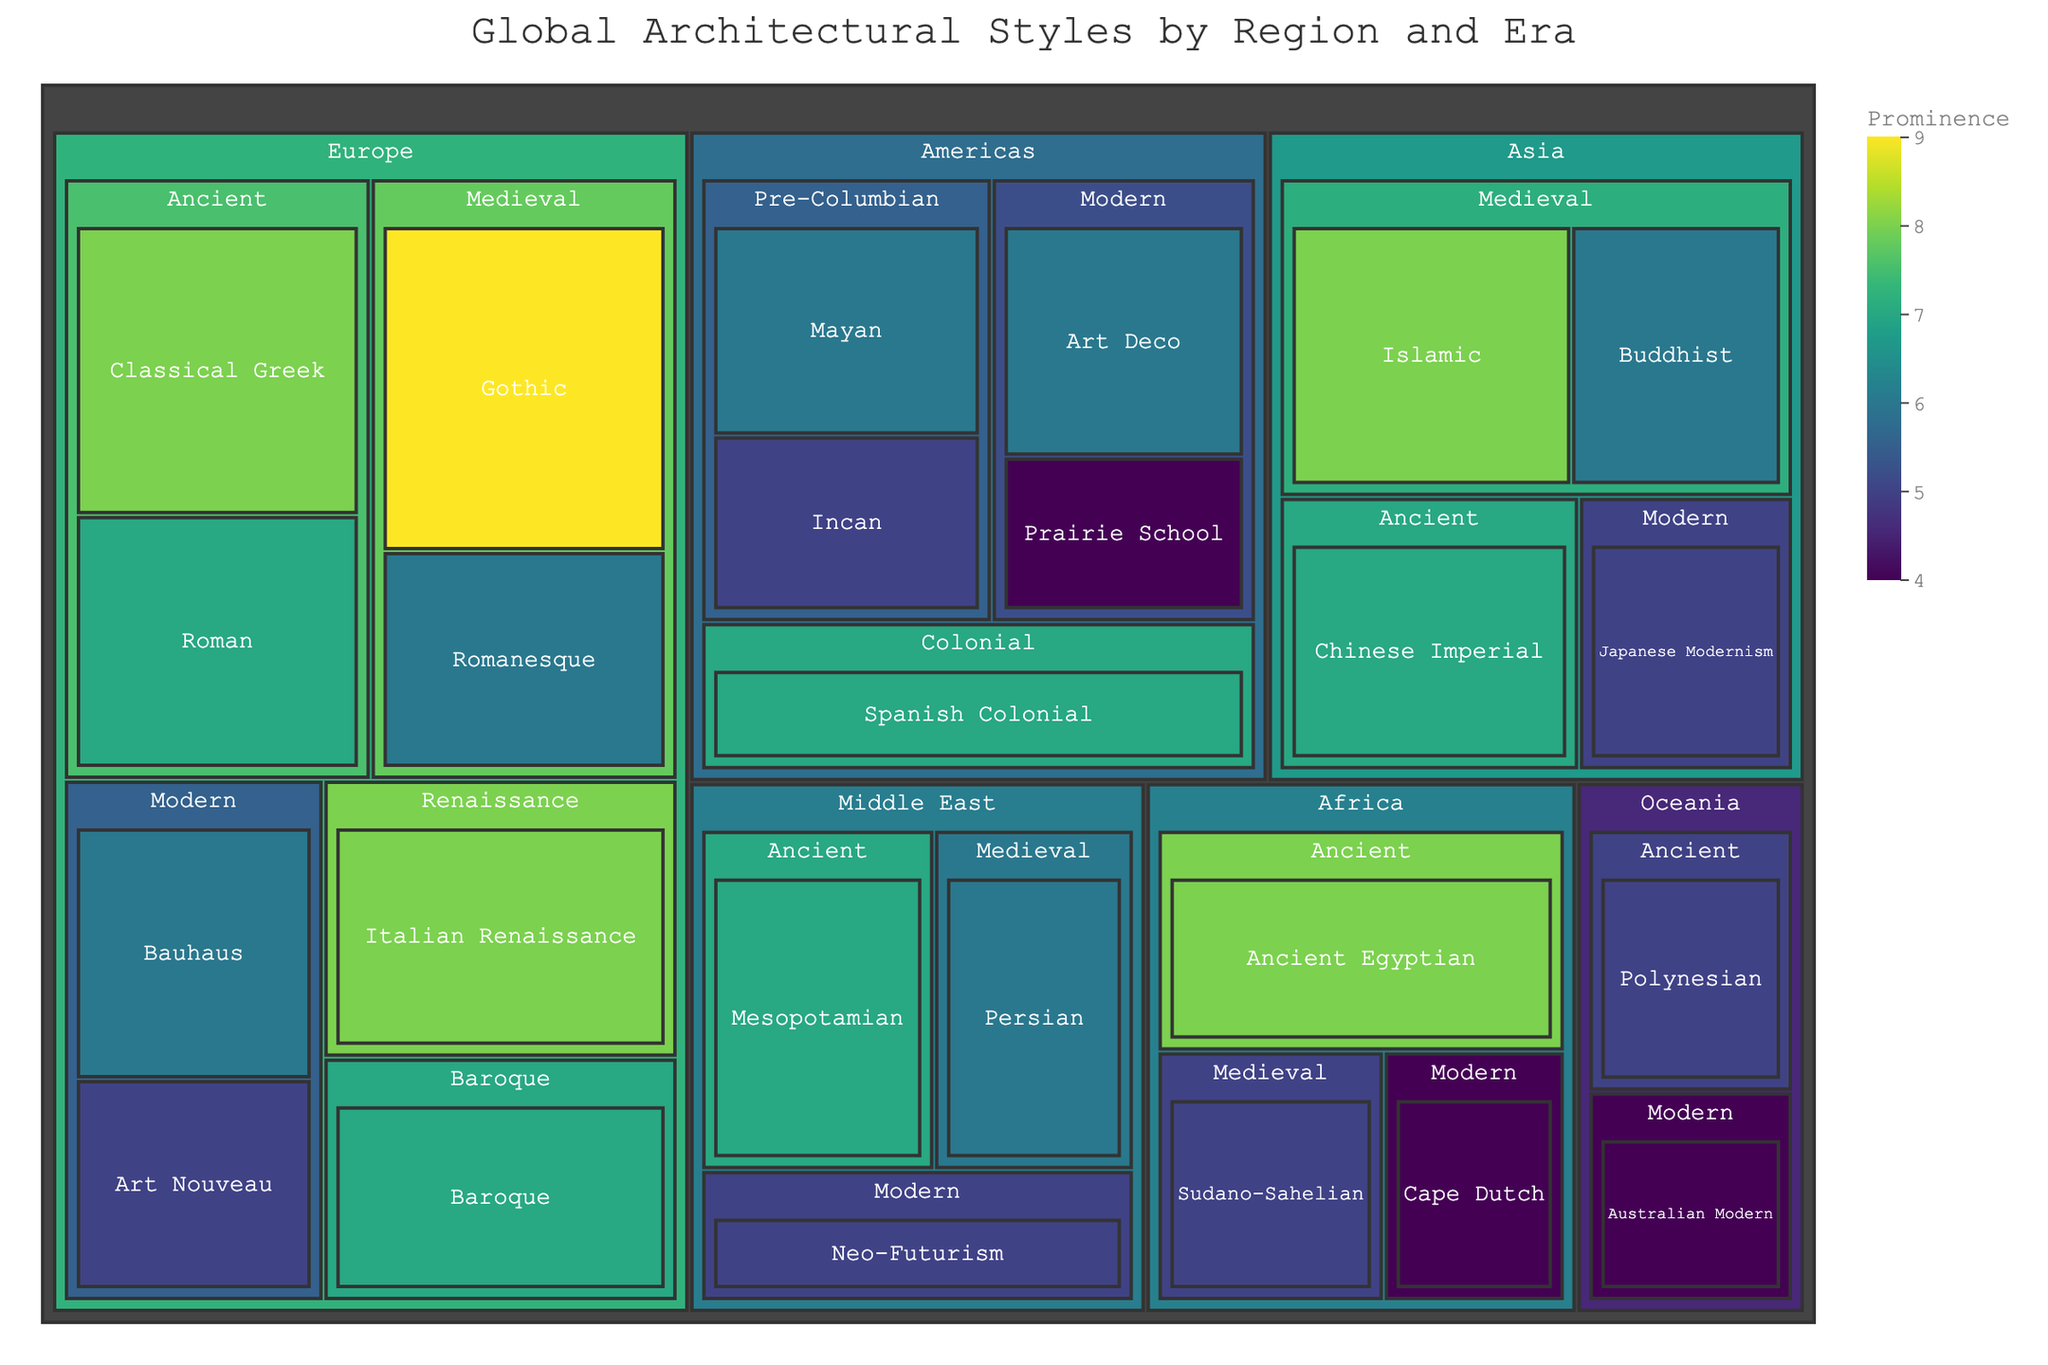What's the title of the treemap? The title can be found at the top of the figure and it summarizes what the treemap represents.
Answer: Global Architectural Styles by Region and Era Which region has the most prominent Gothic architectural style? Look for the Gothic style tile within the 'Europe' region on the treemap. Gothic is noted under the Medieval era.
Answer: Europe Compare the prominence of Classical Greek and Roman architectural styles in the Ancient era in Europe. Which is more prominent? Find the tiles for Classical Greek and Roman styles within the 'Ancient' era under 'Europe'. Compare their prominence values.
Answer: Classical Greek What is the prominence of the Islamic architectural style in Asia during the Medieval era? Locate the Islamic style tile under the 'Medieval' era in the 'Asia' region. The prominence value is displayed there.
Answer: 8 How many architectural styles are under the Americas region? Count all the distinct tiles under the 'Americas' region in the treemap.
Answer: 5 Calculate the total prominence of all architectural styles in the Medieval era in Europe. Sum up the prominence values of Romanesque and Gothic styles in the 'Medieval' era within the 'Europe' region: 6 (Romanesque) + 9 (Gothic) = 15
Answer: 15 Which era does the Japanese Modernism style belong to in Asia? Locate the Japanese Modernism tile in the 'Asia' region and note the era it's categorized under.
Answer: Modern Compare the prominence of any two architectural styles in the Modern era within the Americas. Identify any two styles within the Modern era in the 'Americas' region and compare their prominence values, for example, Prairie School and Art Deco. Art Deco is 6, and Prairie School is 4, so Art Deco is more prominent.
Answer: Art Deco What is the prominence of the Sudano-Sahelian architectural style in Africa during the Medieval era? Find the Sudano-Sahelian style in the 'Medieval' era under the 'Africa' region and check its prominence value.
Answer: 5 Identify the region that has the Mesopotamian architectural style from the Ancient era. Look for the Mesopotamian style in the 'Ancient' era and see which region it falls under.
Answer: Middle East 